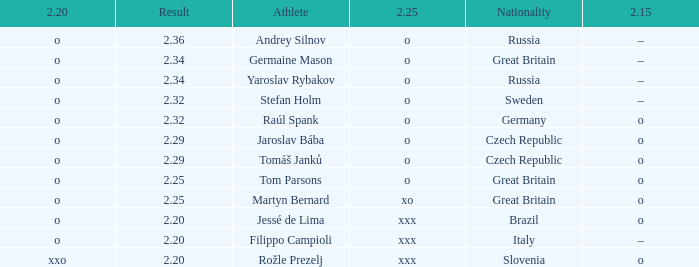What is the 2.15 for Tom Parsons? O. 